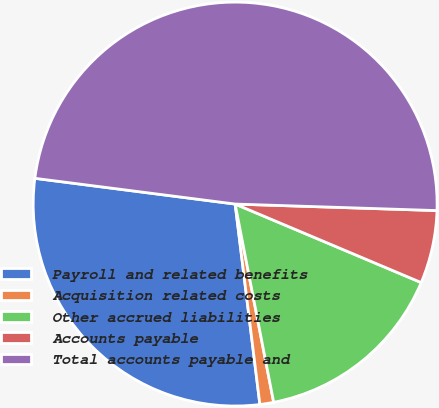<chart> <loc_0><loc_0><loc_500><loc_500><pie_chart><fcel>Payroll and related benefits<fcel>Acquisition related costs<fcel>Other accrued liabilities<fcel>Accounts payable<fcel>Total accounts payable and<nl><fcel>28.99%<fcel>1.1%<fcel>15.59%<fcel>5.84%<fcel>48.48%<nl></chart> 